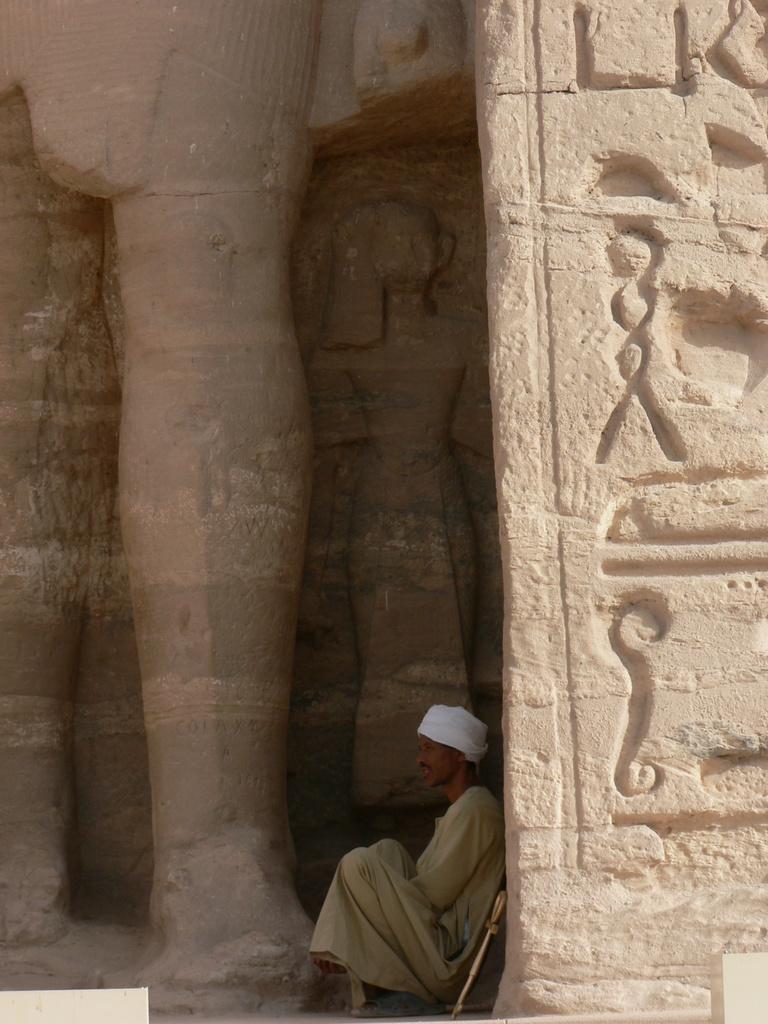Describe this image in one or two sentences. In the picture we can see a sculptured wall near it we can see a man sitting and leaning to it and he is with a white color cap. 